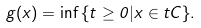<formula> <loc_0><loc_0><loc_500><loc_500>g ( x ) = \inf { \{ t \geq 0 | x \in t C \} } .</formula> 